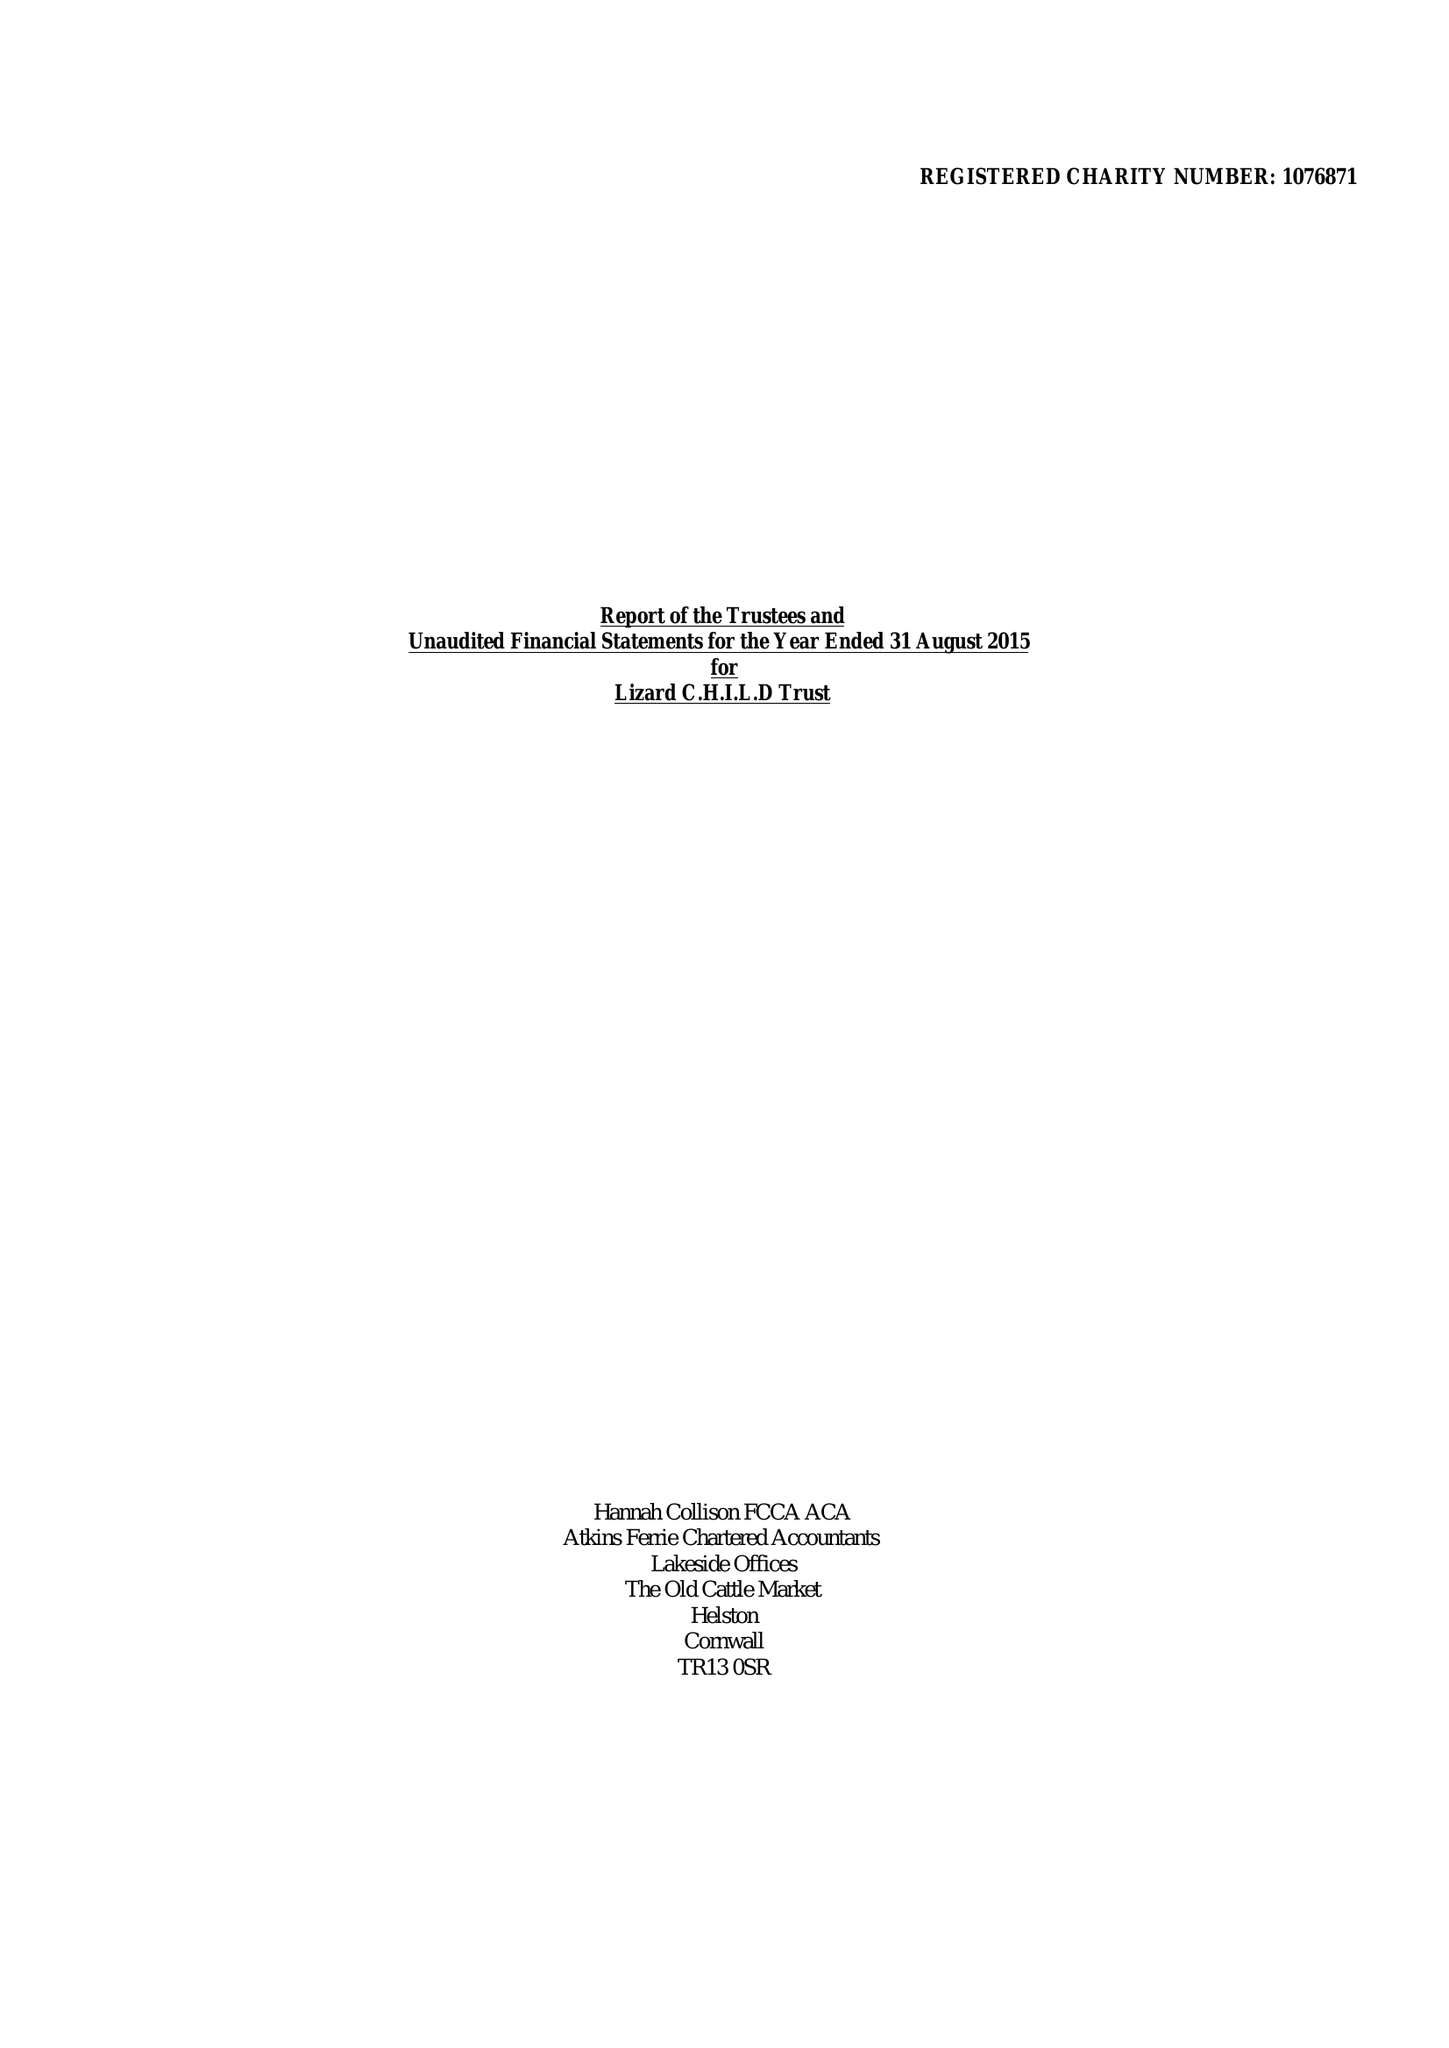What is the value for the report_date?
Answer the question using a single word or phrase. 2015-08-31 